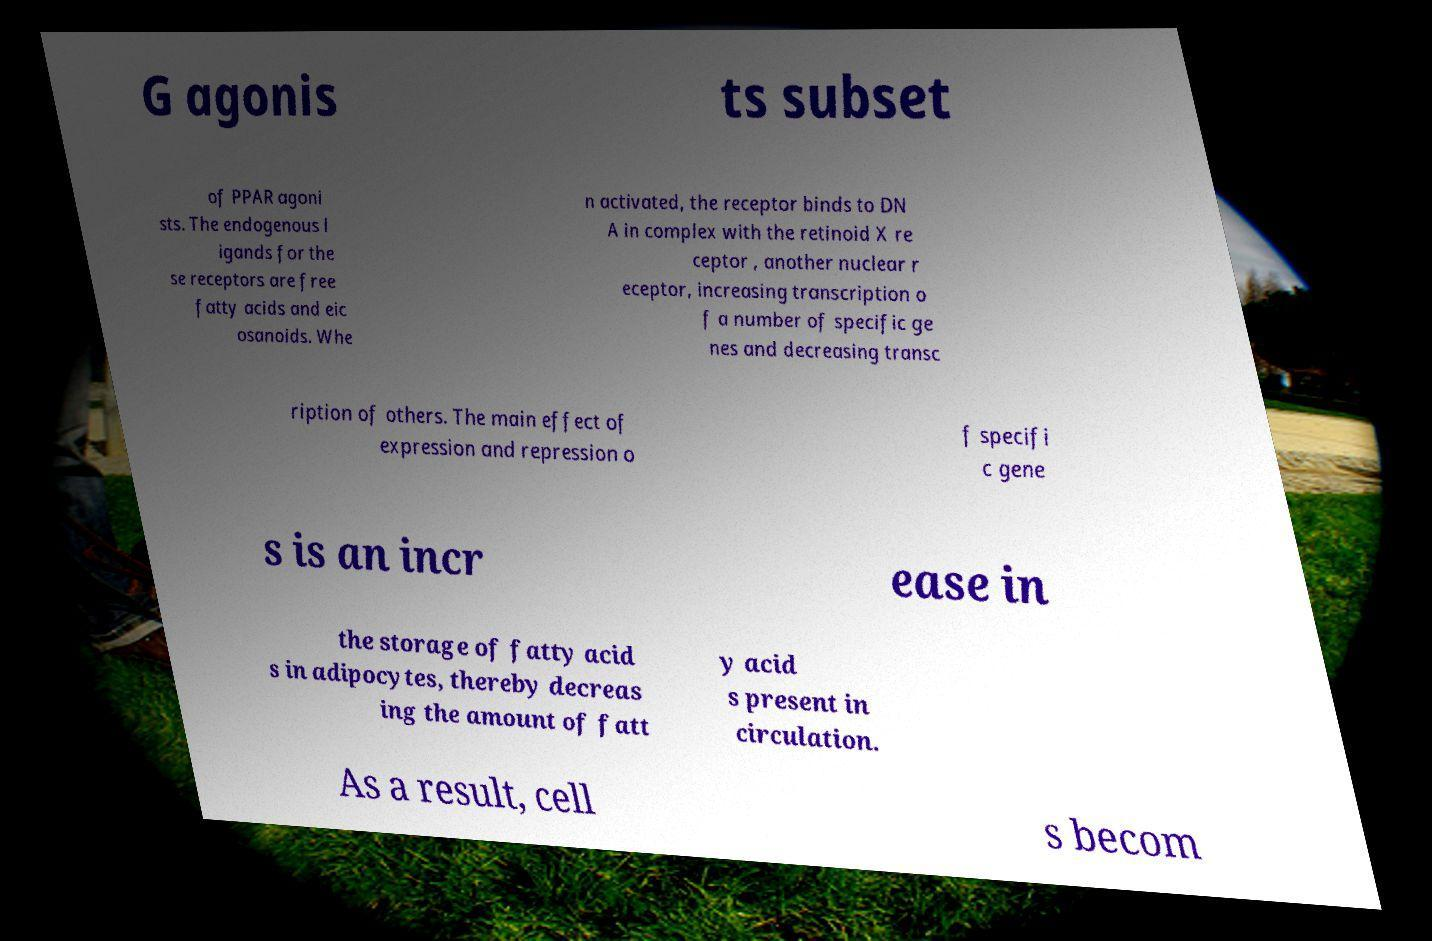For documentation purposes, I need the text within this image transcribed. Could you provide that? G agonis ts subset of PPAR agoni sts. The endogenous l igands for the se receptors are free fatty acids and eic osanoids. Whe n activated, the receptor binds to DN A in complex with the retinoid X re ceptor , another nuclear r eceptor, increasing transcription o f a number of specific ge nes and decreasing transc ription of others. The main effect of expression and repression o f specifi c gene s is an incr ease in the storage of fatty acid s in adipocytes, thereby decreas ing the amount of fatt y acid s present in circulation. As a result, cell s becom 